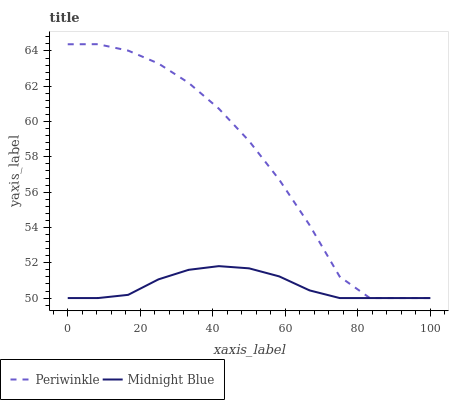Does Midnight Blue have the minimum area under the curve?
Answer yes or no. Yes. Does Periwinkle have the maximum area under the curve?
Answer yes or no. Yes. Does Midnight Blue have the maximum area under the curve?
Answer yes or no. No. Is Midnight Blue the smoothest?
Answer yes or no. Yes. Is Periwinkle the roughest?
Answer yes or no. Yes. Is Midnight Blue the roughest?
Answer yes or no. No. Does Periwinkle have the lowest value?
Answer yes or no. Yes. Does Periwinkle have the highest value?
Answer yes or no. Yes. Does Midnight Blue have the highest value?
Answer yes or no. No. Does Periwinkle intersect Midnight Blue?
Answer yes or no. Yes. Is Periwinkle less than Midnight Blue?
Answer yes or no. No. Is Periwinkle greater than Midnight Blue?
Answer yes or no. No. 